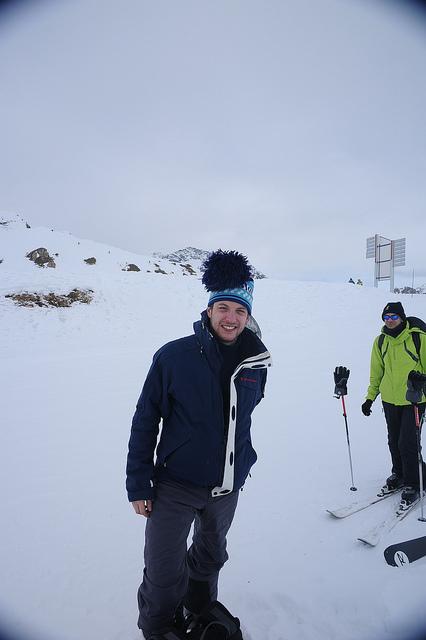Is the snowboarder a guy?
Keep it brief. Yes. Is the guy wearing a jacket?
Write a very short answer. Yes. What covers the ground?
Concise answer only. Snow. Is the man wearing shades?
Keep it brief. No. Is this a sunny day?
Give a very brief answer. No. Is it cold?
Keep it brief. Yes. What is this person wearing?
Answer briefly. Ski clothes. 